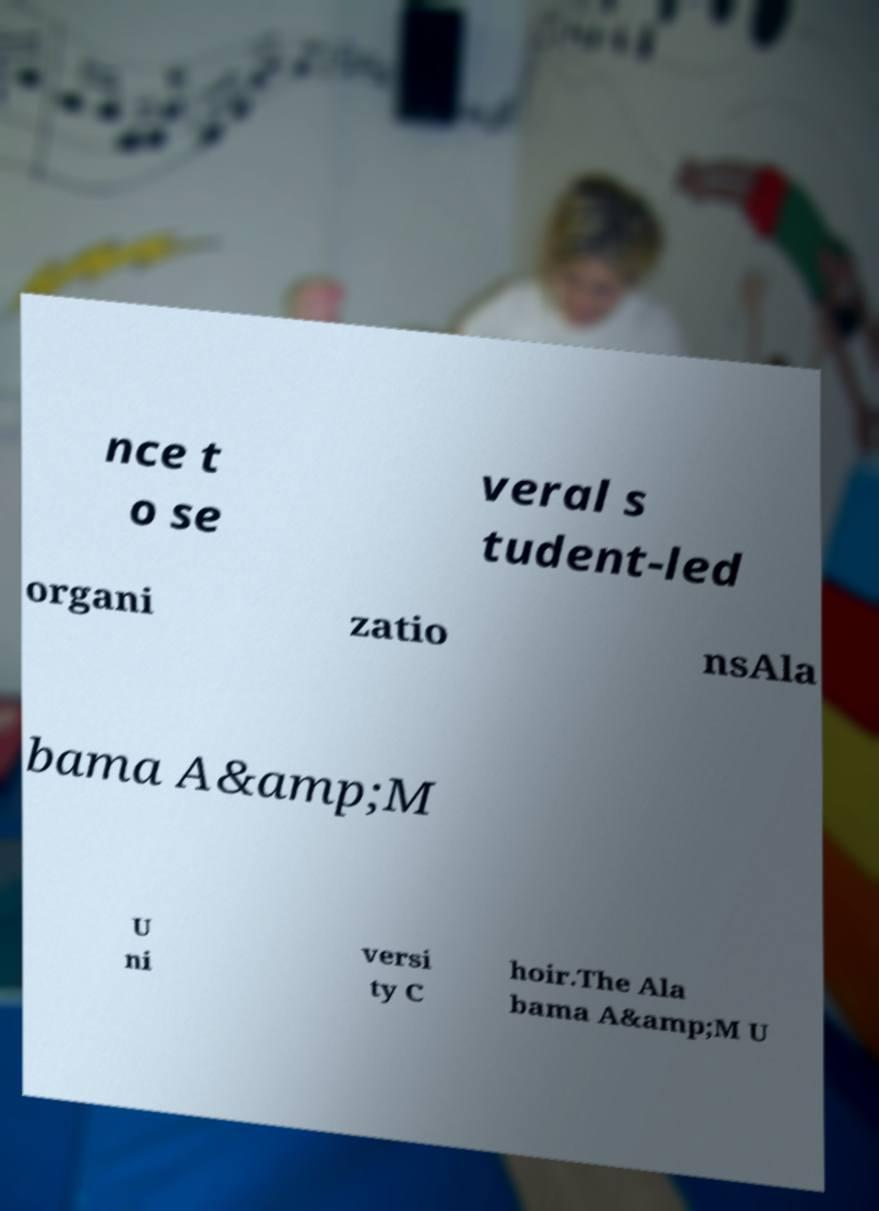Can you read and provide the text displayed in the image?This photo seems to have some interesting text. Can you extract and type it out for me? nce t o se veral s tudent-led organi zatio nsAla bama A&amp;M U ni versi ty C hoir.The Ala bama A&amp;M U 